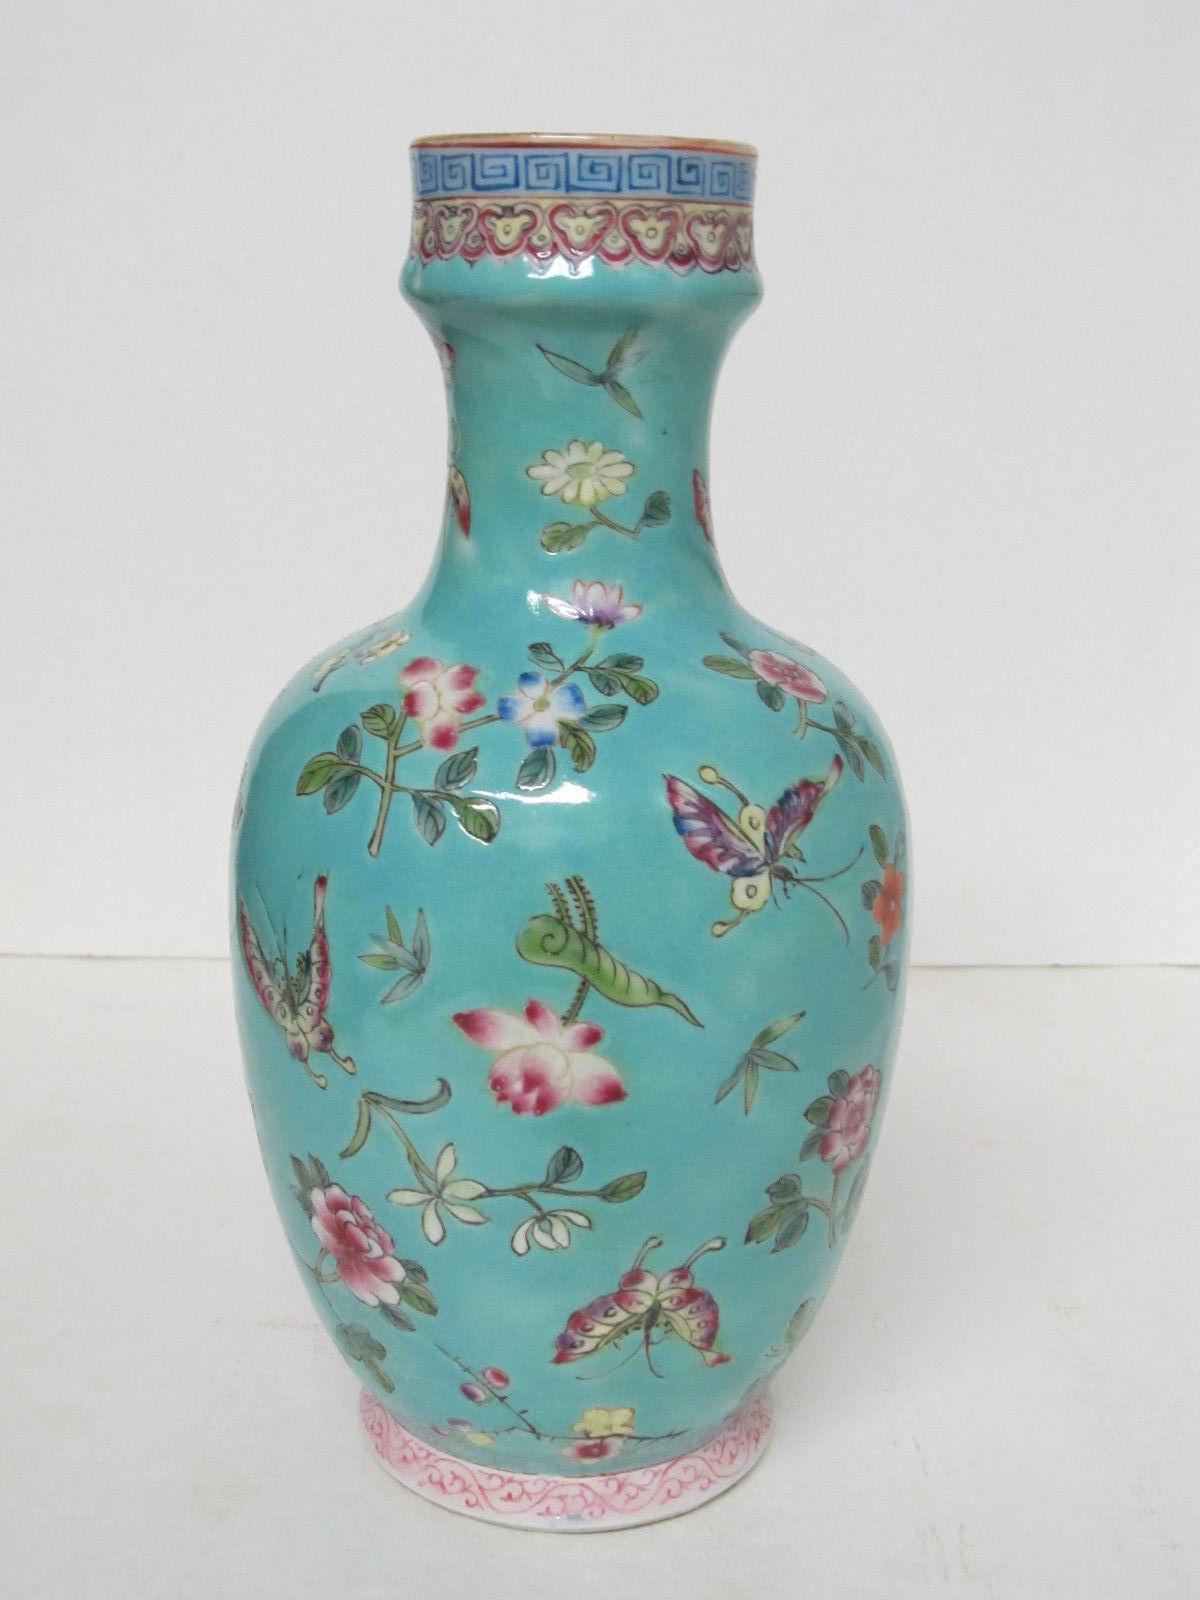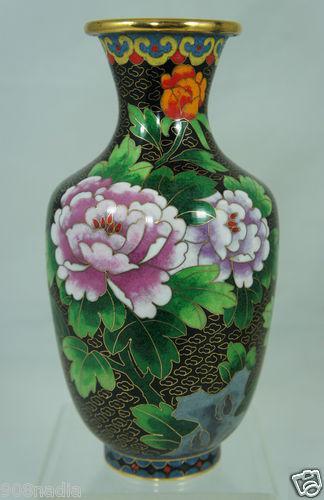The first image is the image on the left, the second image is the image on the right. For the images displayed, is the sentence "One of the vases is predominantly white, while the other is mostly patterned." factually correct? Answer yes or no. No. The first image is the image on the left, the second image is the image on the right. Given the left and right images, does the statement "One vase features a sky-blue background decorated with flowers and flying creatures." hold true? Answer yes or no. Yes. 